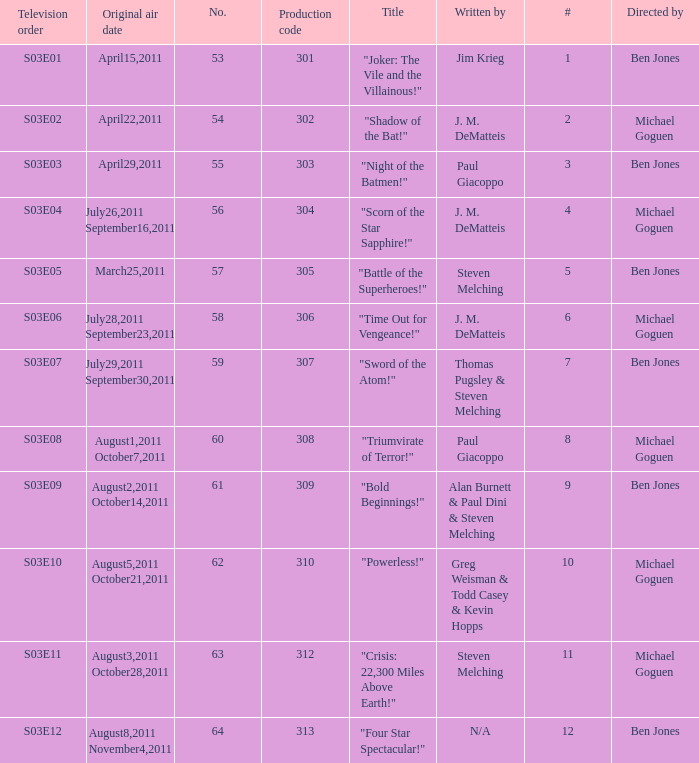What was the original air date for "Crisis: 22,300 Miles Above Earth!"? August3,2011 October28,2011. 